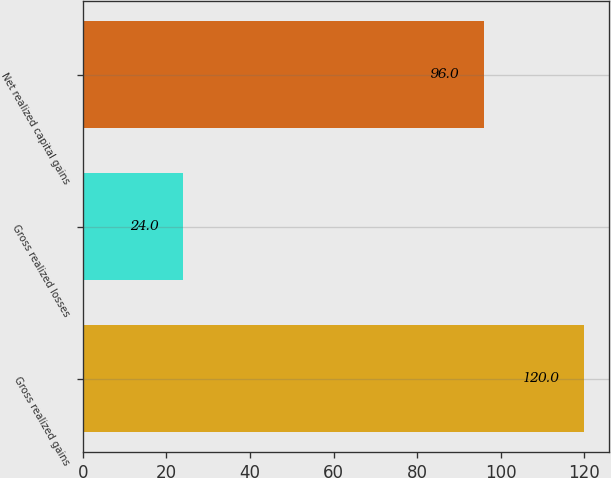<chart> <loc_0><loc_0><loc_500><loc_500><bar_chart><fcel>Gross realized gains<fcel>Gross realized losses<fcel>Net realized capital gains<nl><fcel>120<fcel>24<fcel>96<nl></chart> 